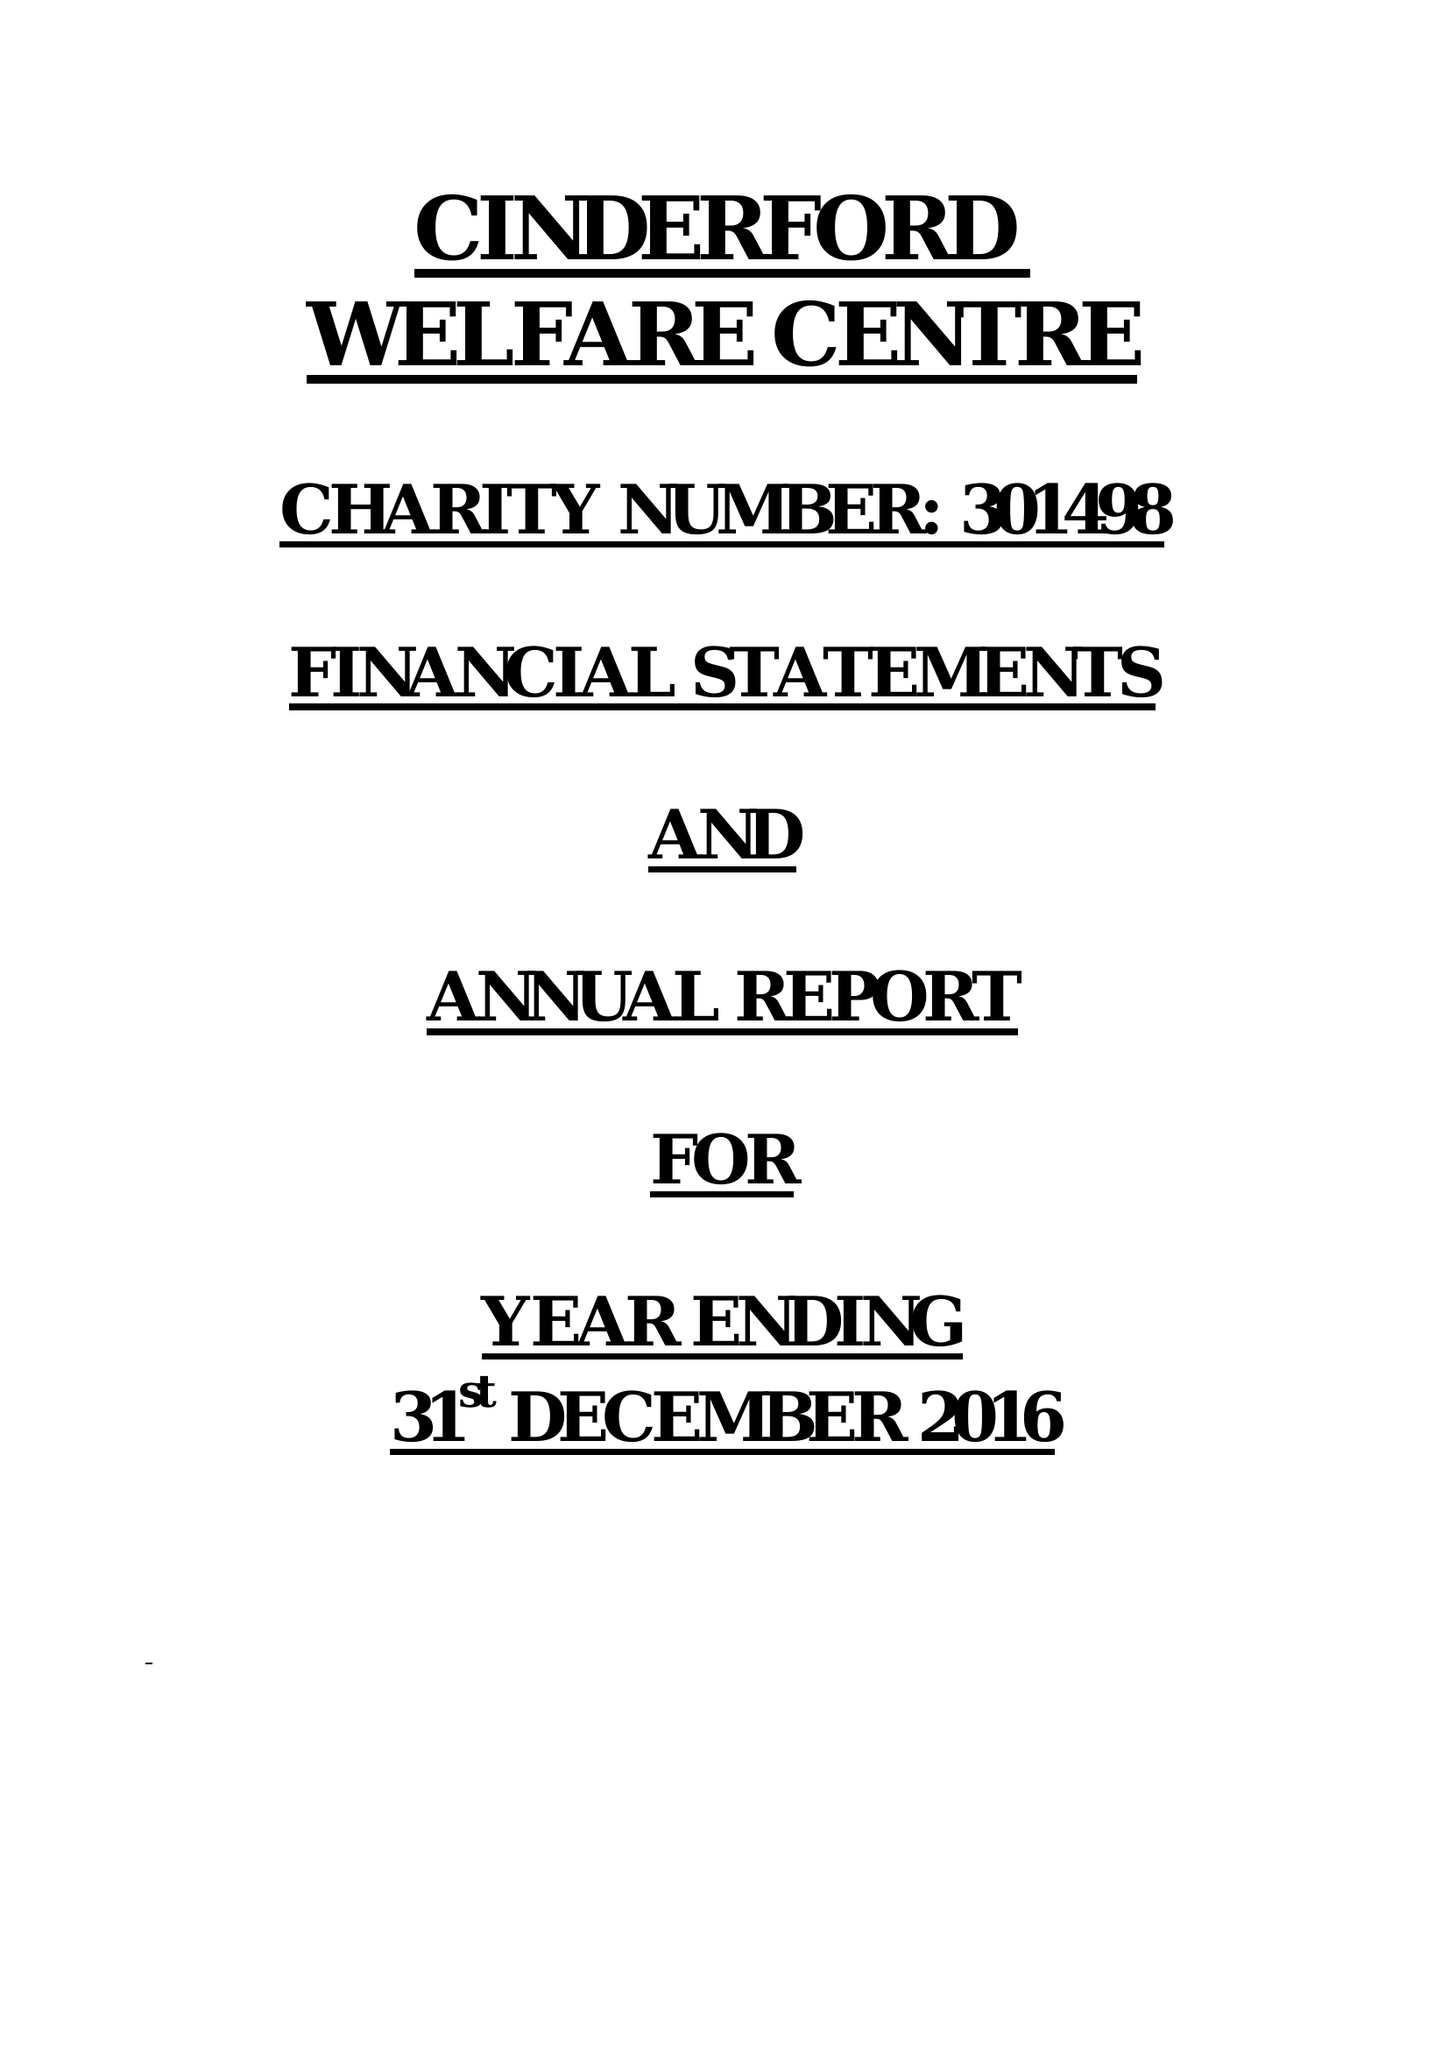What is the value for the charity_number?
Answer the question using a single word or phrase. 301498 